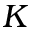<formula> <loc_0><loc_0><loc_500><loc_500>K</formula> 